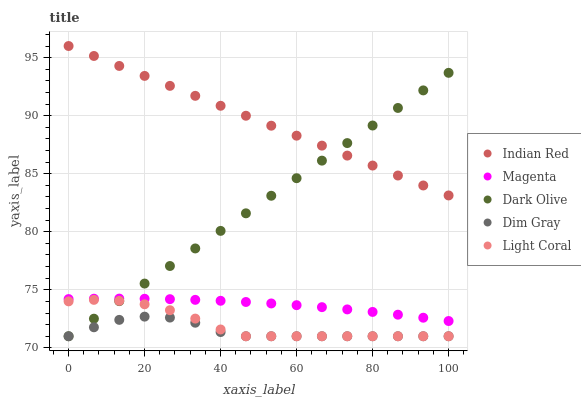Does Dim Gray have the minimum area under the curve?
Answer yes or no. Yes. Does Indian Red have the maximum area under the curve?
Answer yes or no. Yes. Does Light Coral have the minimum area under the curve?
Answer yes or no. No. Does Light Coral have the maximum area under the curve?
Answer yes or no. No. Is Indian Red the smoothest?
Answer yes or no. Yes. Is Dim Gray the roughest?
Answer yes or no. Yes. Is Light Coral the smoothest?
Answer yes or no. No. Is Light Coral the roughest?
Answer yes or no. No. Does Dim Gray have the lowest value?
Answer yes or no. Yes. Does Magenta have the lowest value?
Answer yes or no. No. Does Indian Red have the highest value?
Answer yes or no. Yes. Does Light Coral have the highest value?
Answer yes or no. No. Is Light Coral less than Indian Red?
Answer yes or no. Yes. Is Magenta greater than Dim Gray?
Answer yes or no. Yes. Does Indian Red intersect Dark Olive?
Answer yes or no. Yes. Is Indian Red less than Dark Olive?
Answer yes or no. No. Is Indian Red greater than Dark Olive?
Answer yes or no. No. Does Light Coral intersect Indian Red?
Answer yes or no. No. 